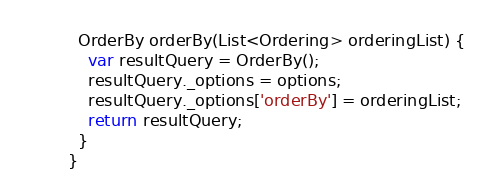<code> <loc_0><loc_0><loc_500><loc_500><_Dart_>
  OrderBy orderBy(List<Ordering> orderingList) {
    var resultQuery = OrderBy();
    resultQuery._options = options;
    resultQuery._options['orderBy'] = orderingList;
    return resultQuery;
  }
}
</code> 